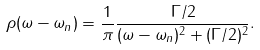Convert formula to latex. <formula><loc_0><loc_0><loc_500><loc_500>\rho ( \omega - \omega _ { n } ) = \frac { 1 } { \pi } \frac { \Gamma / 2 } { ( \omega - \omega _ { n } ) ^ { 2 } + ( \Gamma / 2 ) ^ { 2 } } .</formula> 